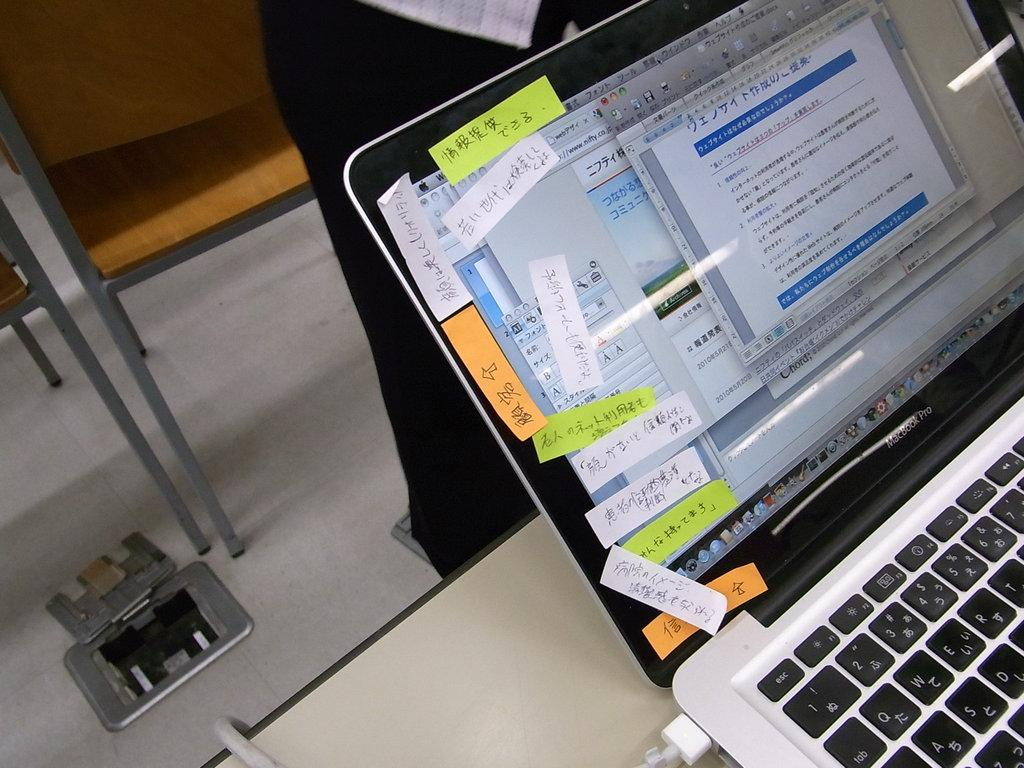Provide a one-sentence caption for the provided image. A bunch of sticky notes are placed on the side of a Macbook Pro. 